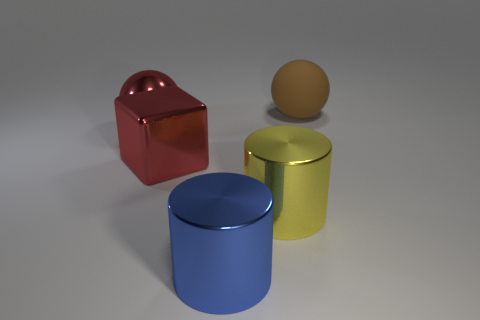Is there any other thing that has the same material as the brown ball?
Make the answer very short. No. What is the shape of the large shiny thing that is the same color as the large metal ball?
Give a very brief answer. Cube. There is a large sphere in front of the large matte sphere; is it the same color as the cube that is behind the big yellow shiny thing?
Your response must be concise. Yes. Is there a yellow object made of the same material as the blue cylinder?
Offer a very short reply. Yes. The block is what color?
Keep it short and to the point. Red. What number of other things are there of the same shape as the big brown object?
Your answer should be compact. 1. What is the color of the thing that is behind the big shiny block and in front of the large matte sphere?
Your answer should be very brief. Red. Do the sphere on the left side of the big rubber ball and the big metal block have the same color?
Provide a succinct answer. Yes. What number of cylinders are large brown matte things or red objects?
Your answer should be very brief. 0. The shiny thing left of the block has what shape?
Offer a terse response. Sphere. 